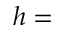<formula> <loc_0><loc_0><loc_500><loc_500>h =</formula> 